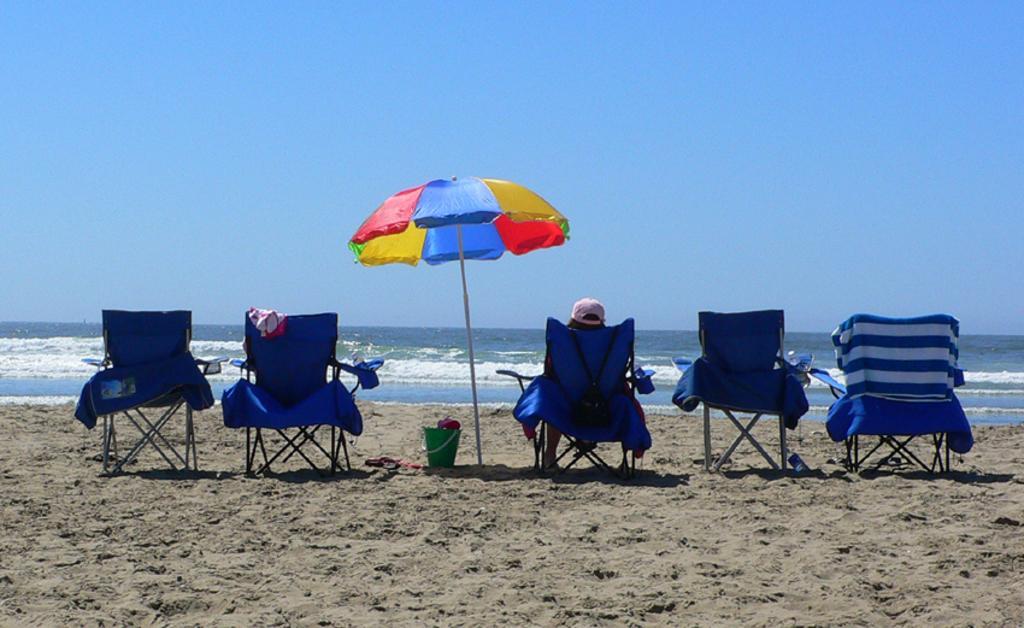Can you describe this image briefly? Here we can see five chairs, umbrella, and a bucket on the sand. There is a person sitting on the chair. In the background we can see water and sky. 